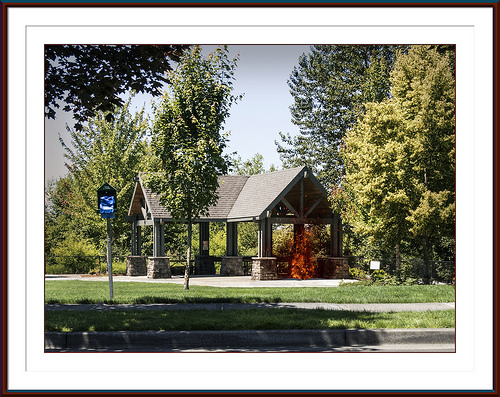<image>
Can you confirm if the signboard is on the grass? No. The signboard is not positioned on the grass. They may be near each other, but the signboard is not supported by or resting on top of the grass. Is there a tree in the house? No. The tree is not contained within the house. These objects have a different spatial relationship. 